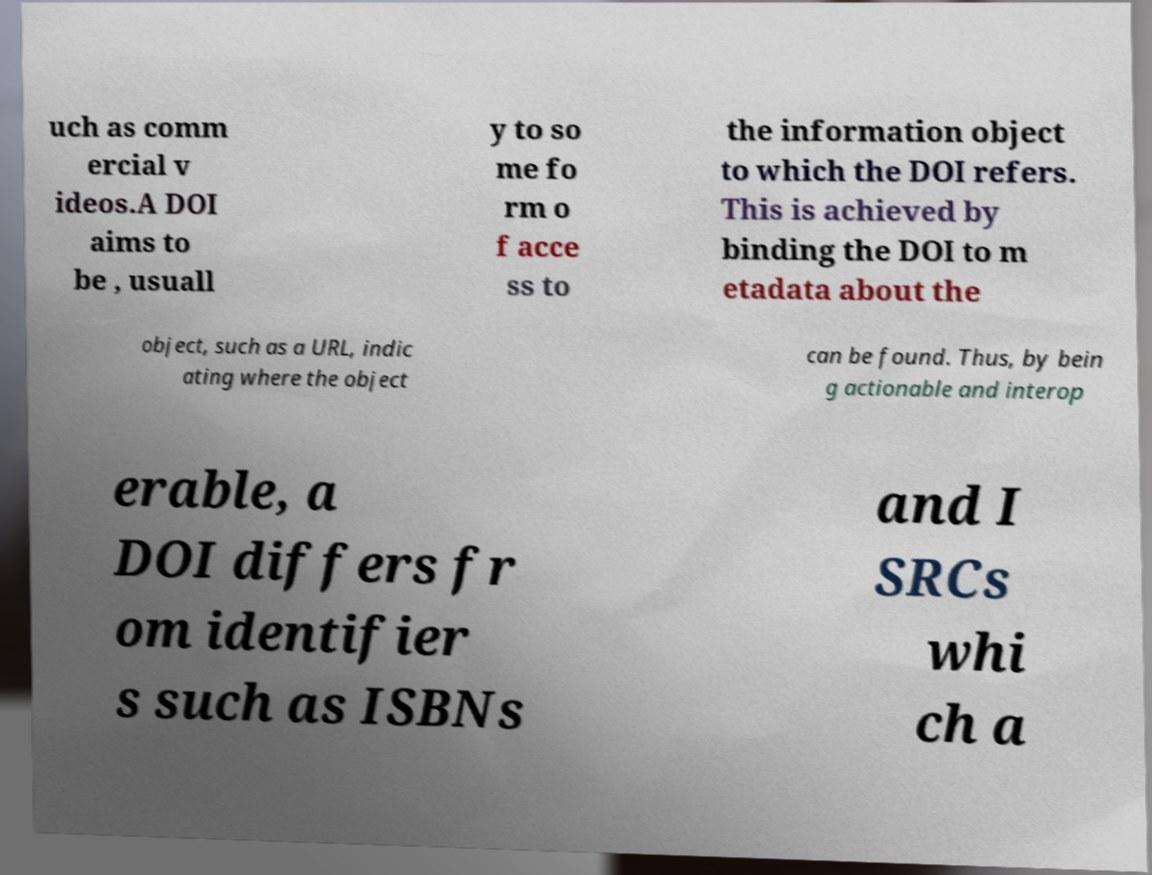For documentation purposes, I need the text within this image transcribed. Could you provide that? uch as comm ercial v ideos.A DOI aims to be , usuall y to so me fo rm o f acce ss to the information object to which the DOI refers. This is achieved by binding the DOI to m etadata about the object, such as a URL, indic ating where the object can be found. Thus, by bein g actionable and interop erable, a DOI differs fr om identifier s such as ISBNs and I SRCs whi ch a 